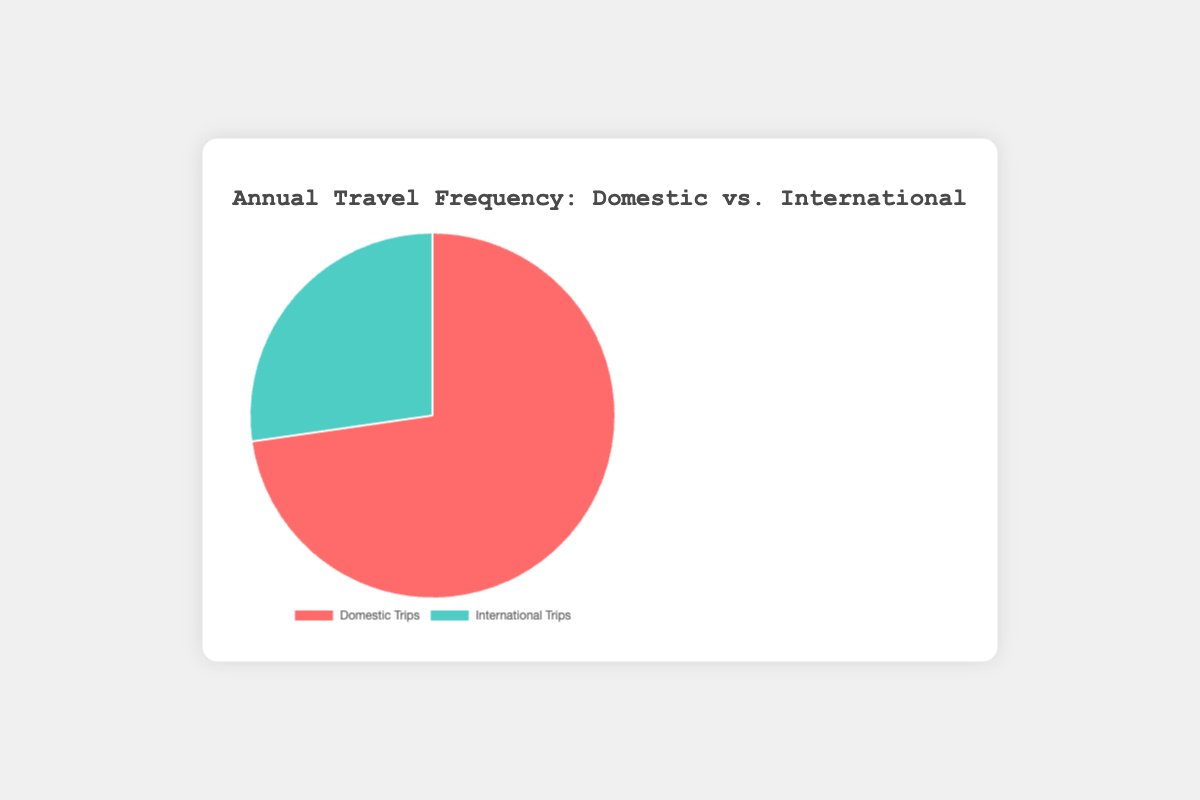How many more domestic trips are made compared to international trips? The figure shows that there are 8 domestic trips and 3 international trips. Subtracting the number of international trips from domestic trips, 8 - 3, we get 5 more domestic trips.
Answer: 5 What is the total number of trips made annually? The figure indicates 8 domestic trips and 3 international trips. Adding these together, 8 + 3, the total number of trips is 11.
Answer: 11 Which type of trip is more frequent? By looking at the figure, we can see that the domestic trips (8) are more frequent than the international trips (3).
Answer: Domestic trips What fraction of the total trips are international trips? First, calculate the total number of trips, which is 8 domestic trips + 3 international trips = 11 trips. Then, the fraction of international trips is 3/11.
Answer: 3/11 What is the percentage of domestic trips out of the total trips? Calculate the total number of trips (8 + 3 = 11). Then, the percentage of domestic trips is (8/11) * 100.
Answer: 72.73% What is the color associated with international trips in the pie chart? The visual attribute of the international trips segment is colored green (or similar shade).
Answer: Green How much larger is the domestic trips segment compared to the international trips segment in terms of trips? The domestic trips segment shows 8 trips while the international trips segment shows 3 trips. The difference is 8 - 3 = 5 trips.
Answer: 5 Is the proportion of domestic trips more than double the proportion of international trips? The proportion of domestic trips is 8/11 and the proportion of international trips is 3/11. Doubling the proportion of international trips gives us (3/11) * 2 = 6/11. Since 8/11 > 6/11, the proportion of domestic trips is more than double the proportion of international trips.
Answer: Yes If an average month has equal travel frequency, how many international trips are made per month? The figure indicates there are 3 international trips annually. Dividing by 12 months gives 3/12 = 0.25 international trips per month.
Answer: 0.25 If the total number of trips next year increases by 5 and this increase is evenly split between domestic and international trips, how many trips will be domestic and international respectively? Currently, there are 8 domestic and 3 international trips, making a total of 11 trips. If the number of trips increases by 5 and divided equally, each type of trip increases by 5/2 = 2.5. Hence, domestic trips will be 8 + 2.5 = 10.5 and international trips will be 3 + 2.5 = 5.5.
Answer: Domestic: 10.5, International: 5.5 